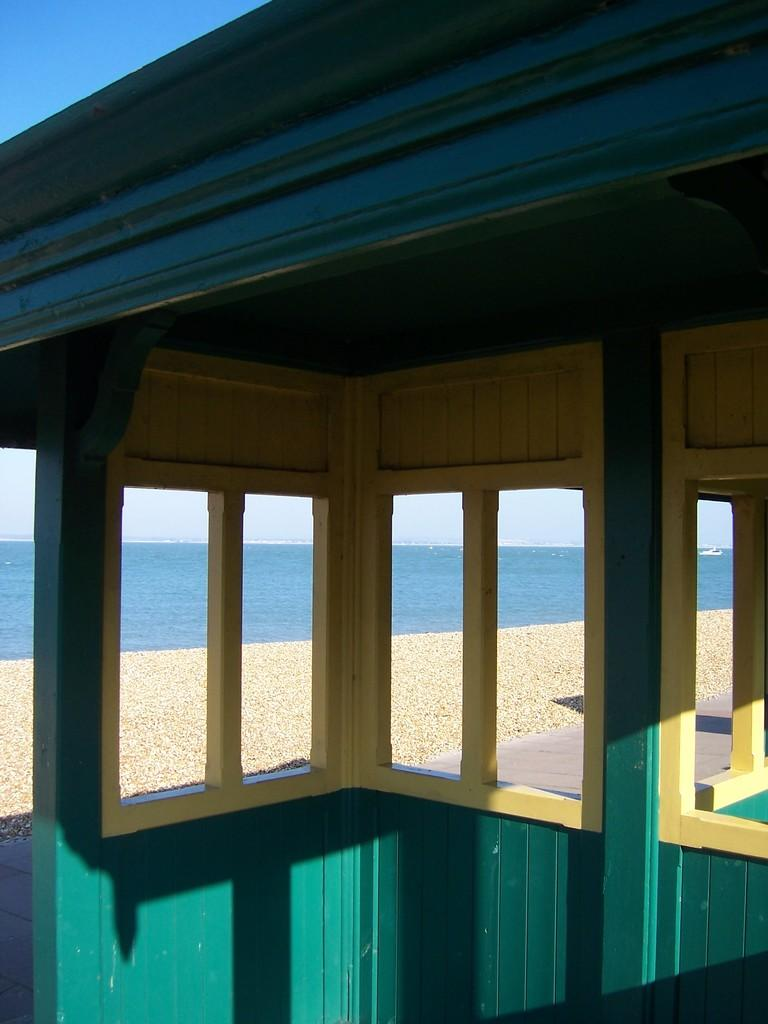What structure is located on the ground in the image? There is a shed on the ground in the image. What is located on water in the image? There is a boat on water in the image. What can be seen in the background of the image? The sky is visible in the background of the image. What type of farm animals can be seen grazing near the shed in the image? There are no farm animals present in the image; it only features a shed and a boat on water. What is the condition of the fire in the image? There is no fire present in the image. 